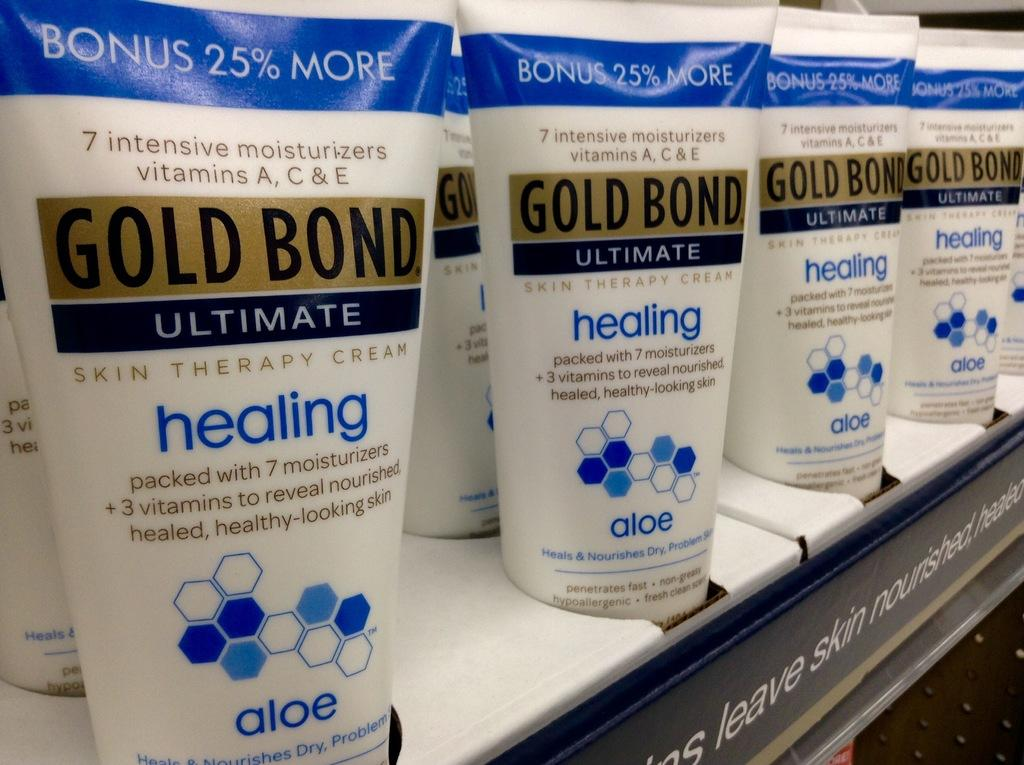<image>
Summarize the visual content of the image. Gold Bond Ultimate is for sale at a store. 